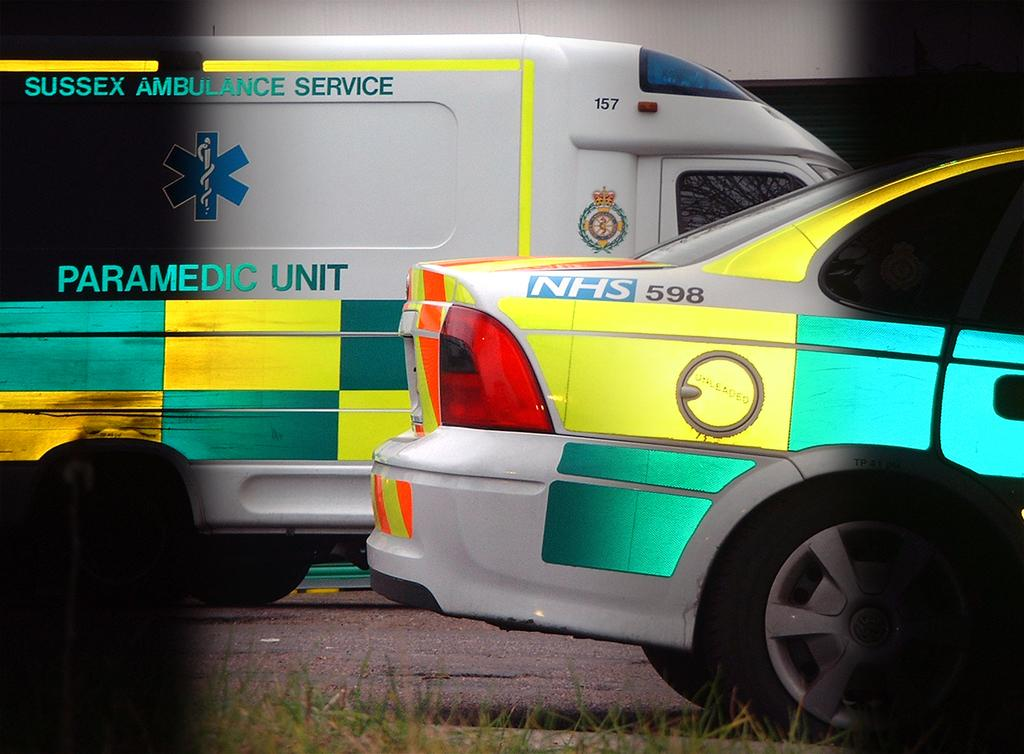<image>
Offer a succinct explanation of the picture presented. A Sussex ambulance paramedic group just beyond another service sedan 